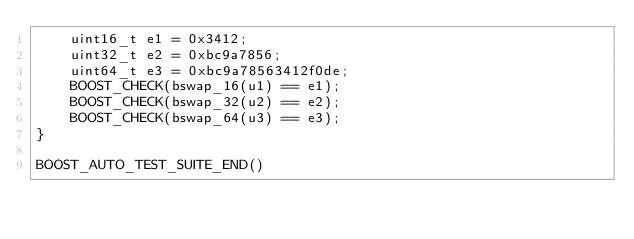Convert code to text. <code><loc_0><loc_0><loc_500><loc_500><_C++_>	uint16_t e1 = 0x3412;
	uint32_t e2 = 0xbc9a7856;
	uint64_t e3 = 0xbc9a78563412f0de;
	BOOST_CHECK(bswap_16(u1) == e1);
	BOOST_CHECK(bswap_32(u2) == e2);
	BOOST_CHECK(bswap_64(u3) == e3);
}

BOOST_AUTO_TEST_SUITE_END()
</code> 